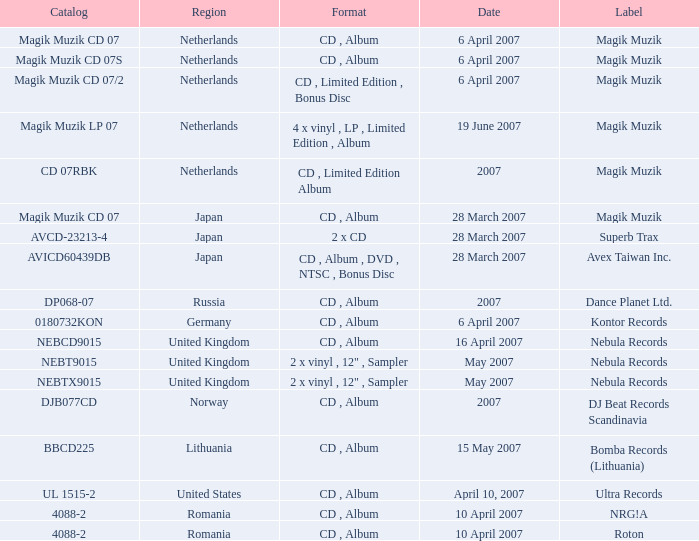For the catalog title DP068-07, what formats are available? CD , Album. 